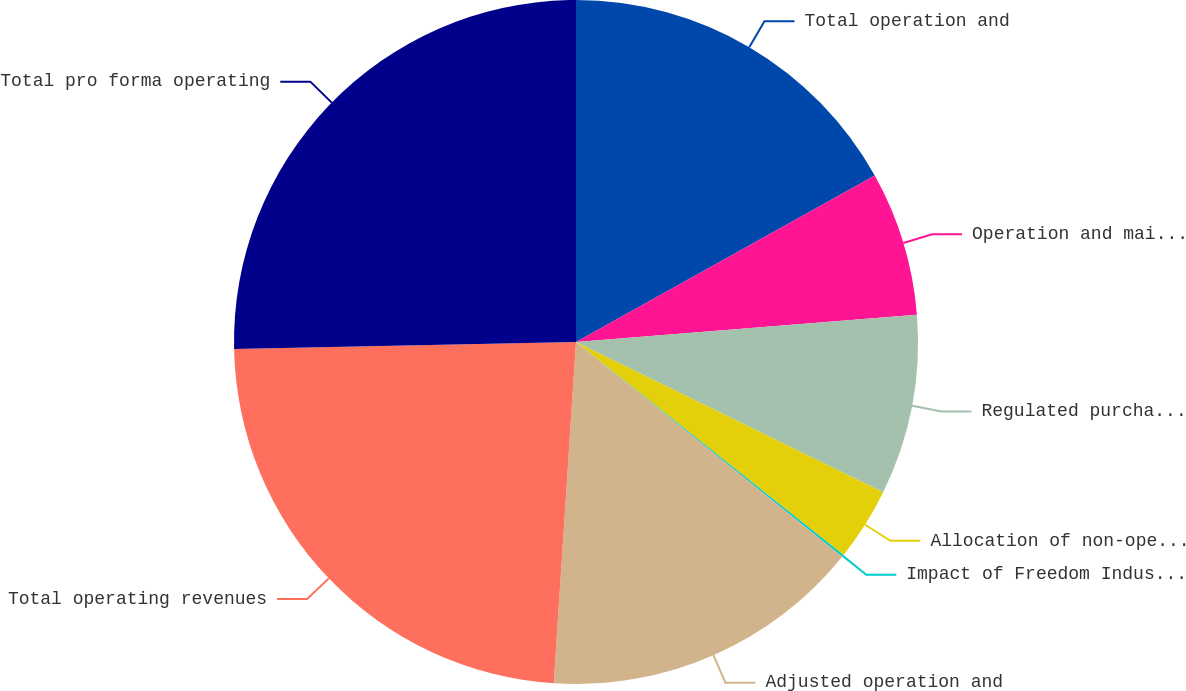Convert chart to OTSL. <chart><loc_0><loc_0><loc_500><loc_500><pie_chart><fcel>Total operation and<fcel>Operation and maintenance<fcel>Regulated purchased water<fcel>Allocation of non-operation<fcel>Impact of Freedom Industries<fcel>Adjusted operation and<fcel>Total operating revenues<fcel>Total pro forma operating<nl><fcel>16.91%<fcel>6.82%<fcel>8.51%<fcel>3.46%<fcel>0.1%<fcel>15.23%<fcel>23.64%<fcel>25.32%<nl></chart> 